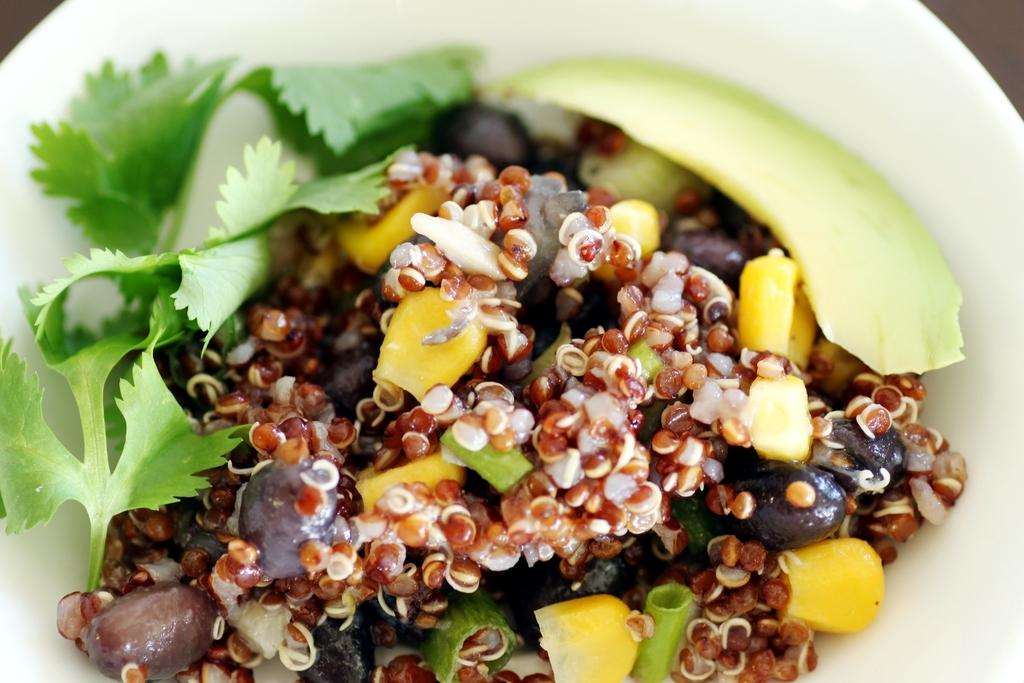What is present in the image? There is a bowl in the image. What is inside the bowl? The bowl contains food. What type of liquid is being poured from the bottle in the image? There is no bottle present in the image, so it is not possible to answer that question. 